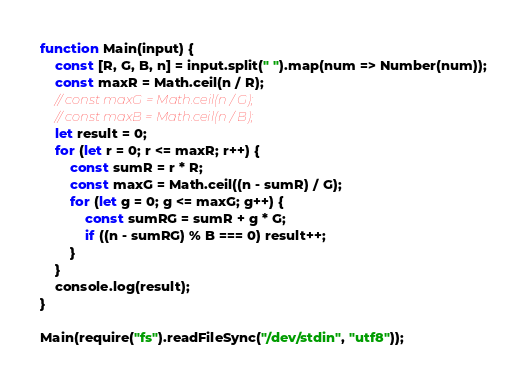<code> <loc_0><loc_0><loc_500><loc_500><_TypeScript_>function Main(input) {
    const [R, G, B, n] = input.split(" ").map(num => Number(num));
    const maxR = Math.ceil(n / R);
    // const maxG = Math.ceil(n / G);
    // const maxB = Math.ceil(n / B);
    let result = 0;
    for (let r = 0; r <= maxR; r++) {
        const sumR = r * R;
        const maxG = Math.ceil((n - sumR) / G);
        for (let g = 0; g <= maxG; g++) {
            const sumRG = sumR + g * G;
            if ((n - sumRG) % B === 0) result++;
        }
    }
    console.log(result);
}

Main(require("fs").readFileSync("/dev/stdin", "utf8"));</code> 